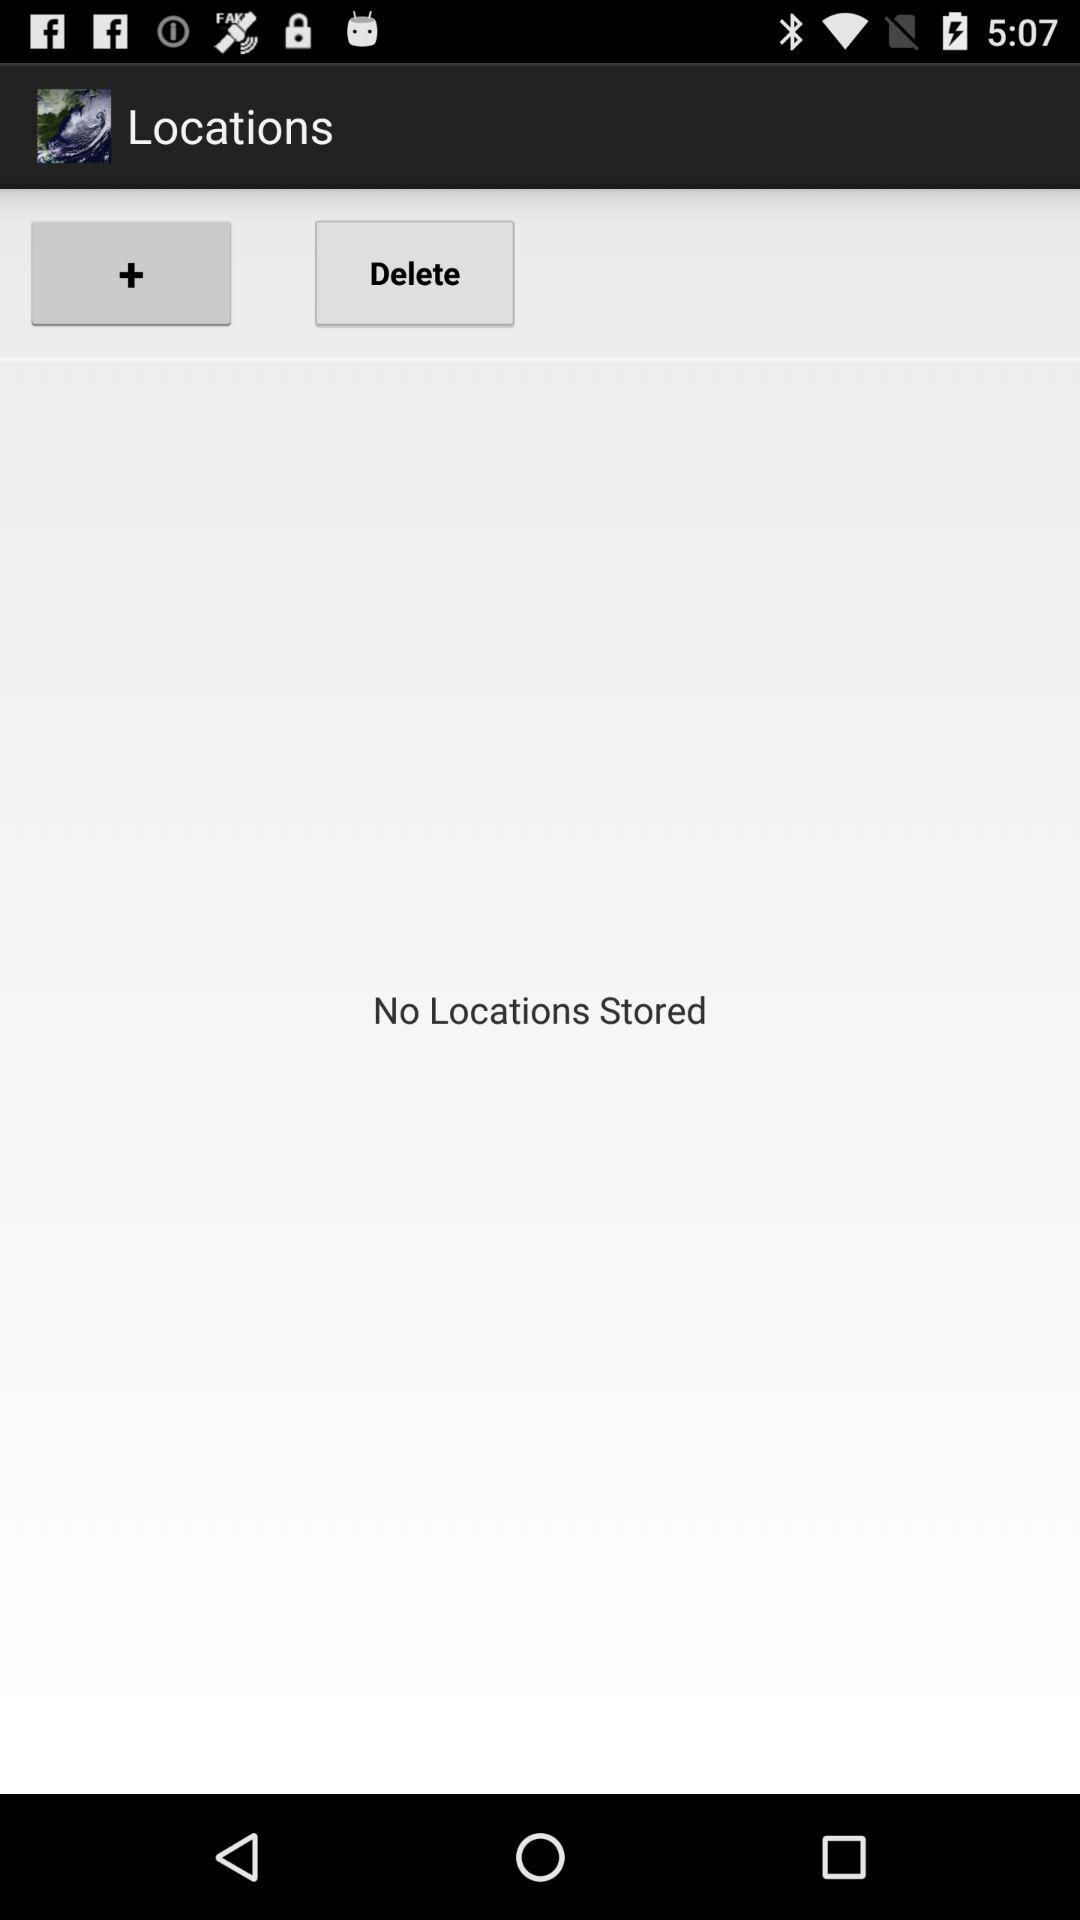How many locations are currently stored?
Answer the question using a single word or phrase. 0 